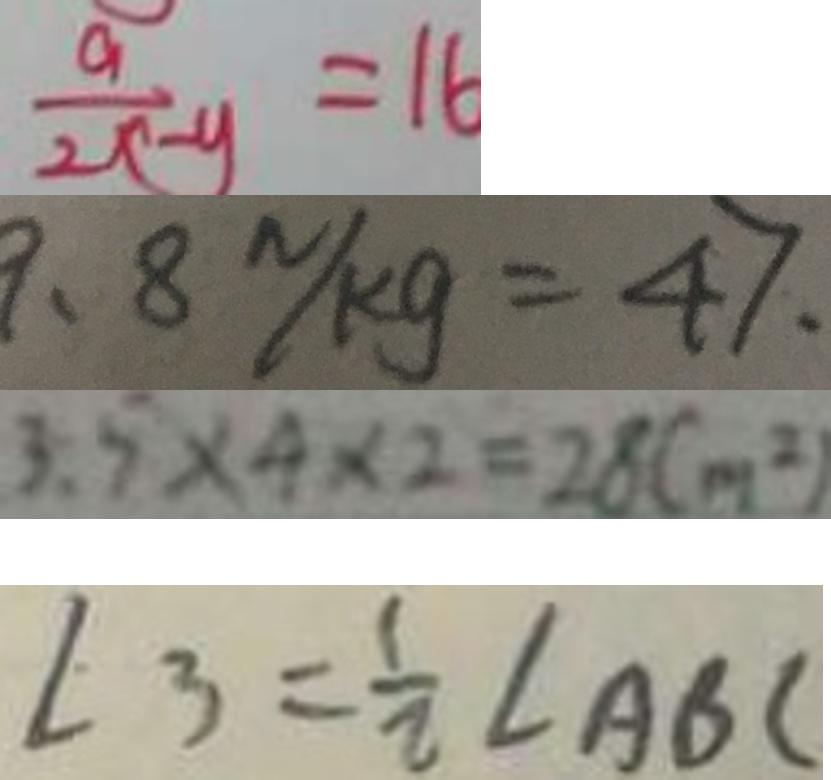<formula> <loc_0><loc_0><loc_500><loc_500>\frac { a } { 2 x - y } = 1 6 
 9 . 8 N / k g = 4 7 . 
 3 . 5 \times 4 \times 2 = 2 8 ( m ^ { 2 } ) 
 \angle 3 = \frac { 1 } { 2 } \angle A B C</formula> 